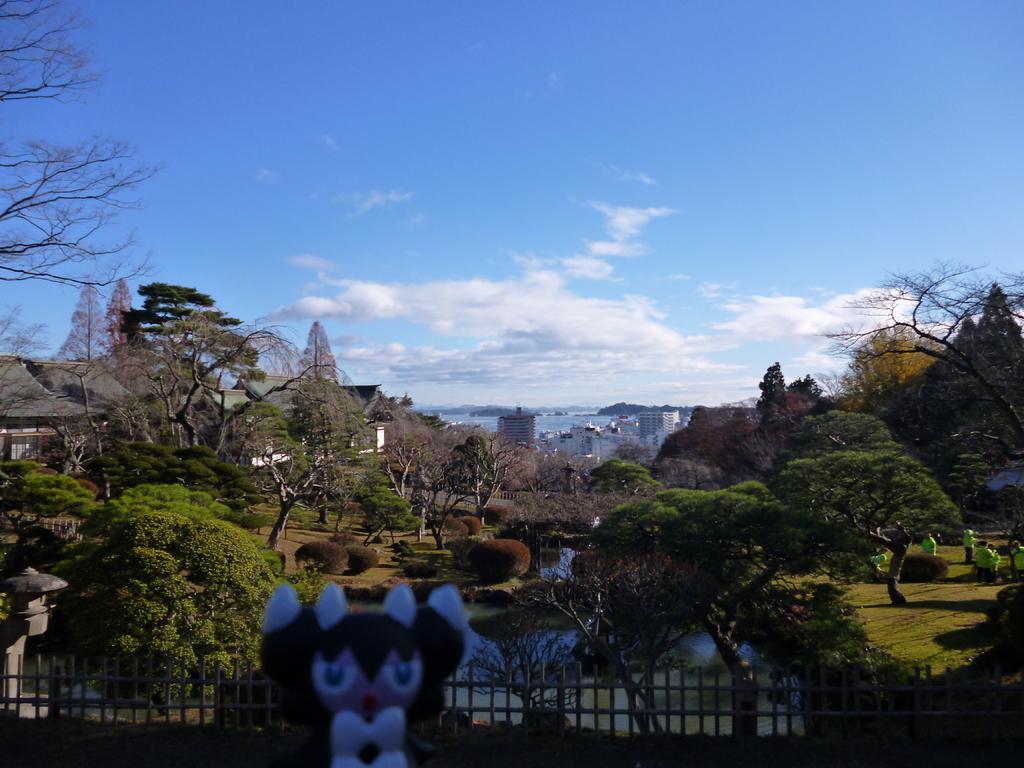Describe this image in one or two sentences. In this image I can see there are trees and bushes visible in the middle and I can see persons on right side and at the top I can see the sky and at the bottom I can see fence and toy and in the middle there are buildings visible 